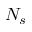<formula> <loc_0><loc_0><loc_500><loc_500>N _ { s }</formula> 